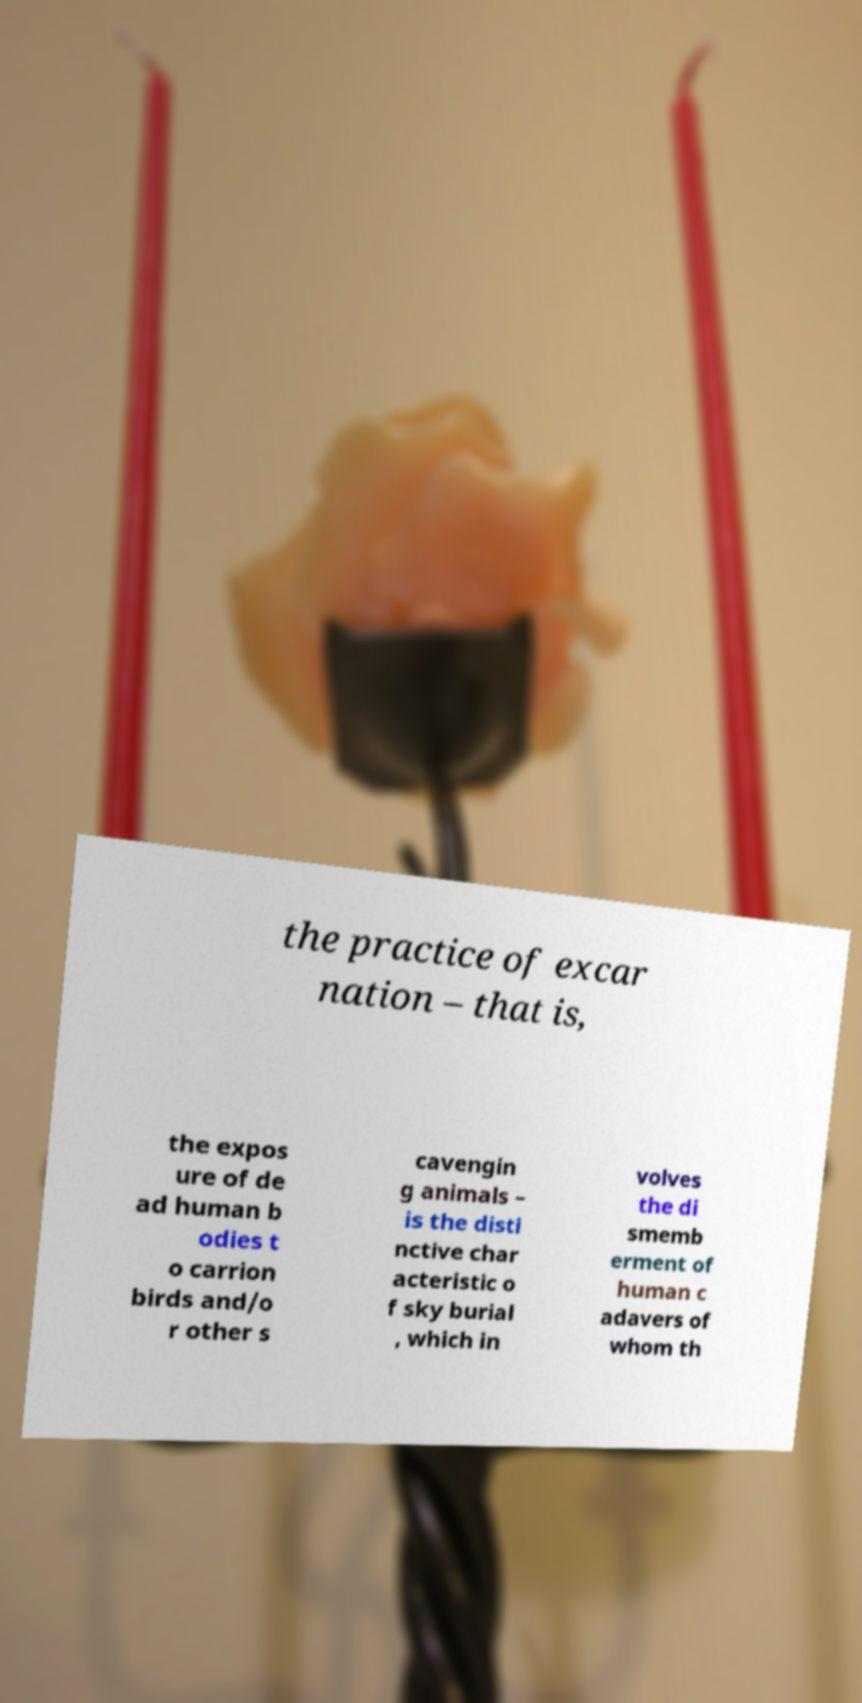There's text embedded in this image that I need extracted. Can you transcribe it verbatim? the practice of excar nation – that is, the expos ure of de ad human b odies t o carrion birds and/o r other s cavengin g animals – is the disti nctive char acteristic o f sky burial , which in volves the di smemb erment of human c adavers of whom th 